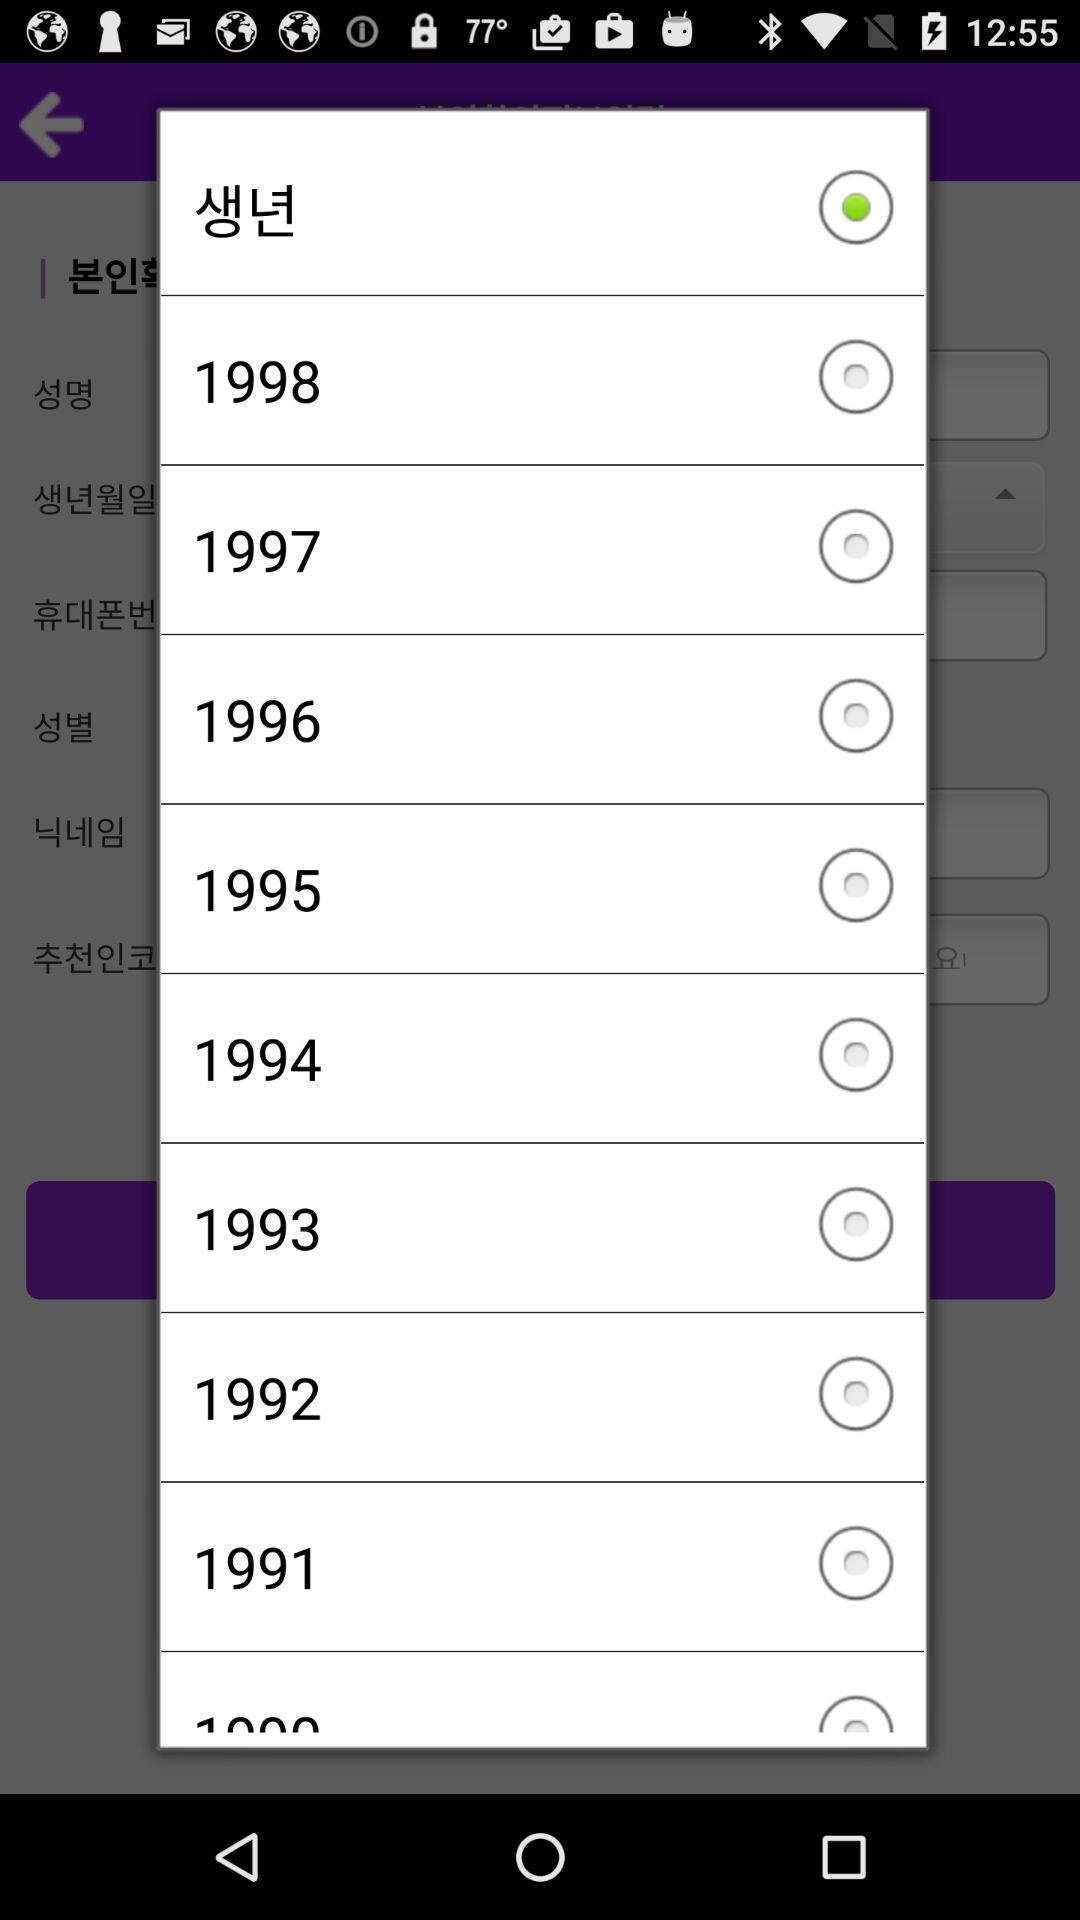How many years are before 1998?
Answer the question using a single word or phrase. 8 